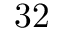Convert formula to latex. <formula><loc_0><loc_0><loc_500><loc_500>3 2</formula> 